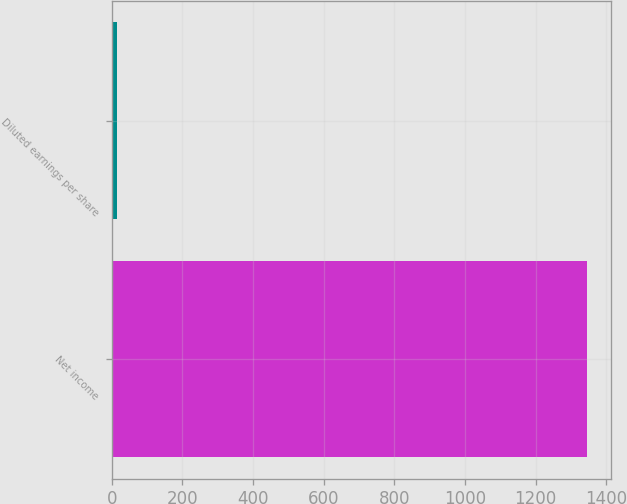<chart> <loc_0><loc_0><loc_500><loc_500><bar_chart><fcel>Net income<fcel>Diluted earnings per share<nl><fcel>1346<fcel>15.73<nl></chart> 